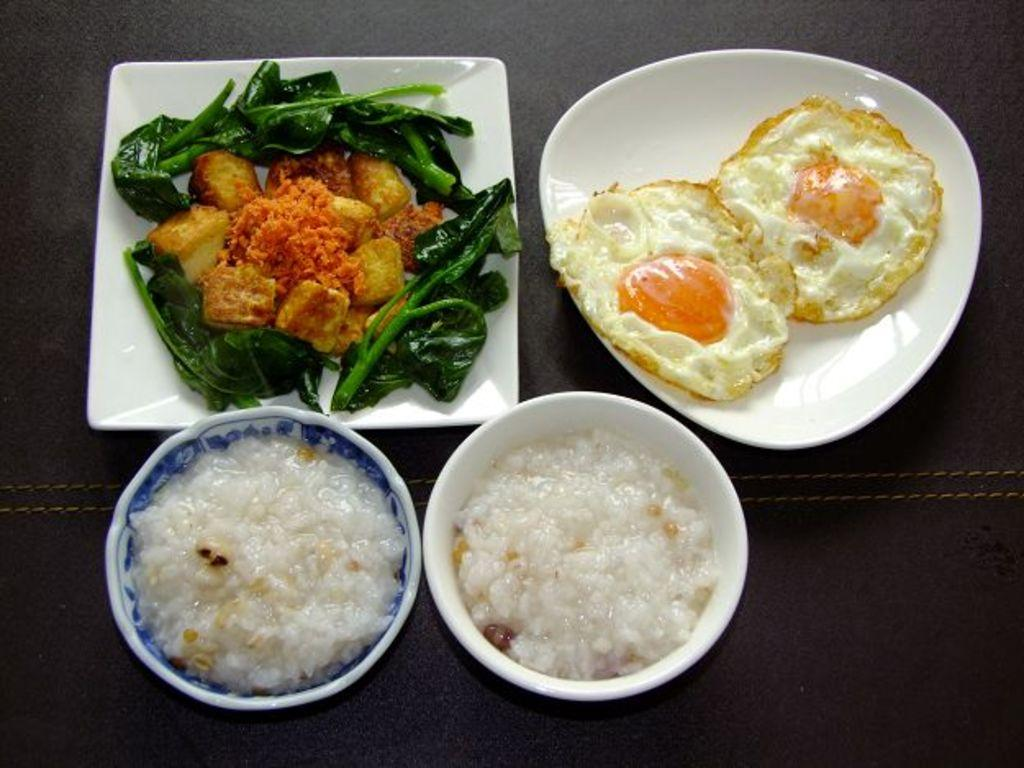How many plates with food are visible in the image? There are four plates with food visible in the image. Where are the plates placed in the image? The plates are placed on a surface in the image. How many bikes can be seen parked near the plates in the image? There are no bikes present in the image. Is the food served on the plates in the image being eaten by sea creatures? There is no indication of sea creatures or any marine environment in the image. How many centimeters tall is the tallest centaur in the image? There are no centaurs present in the image. 